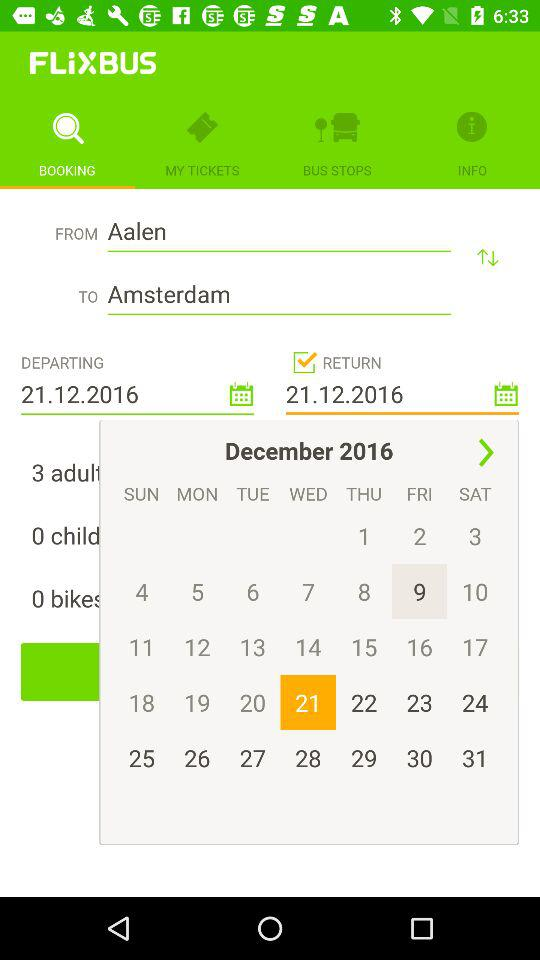Who is making this booking?
When the provided information is insufficient, respond with <no answer>. <no answer> 